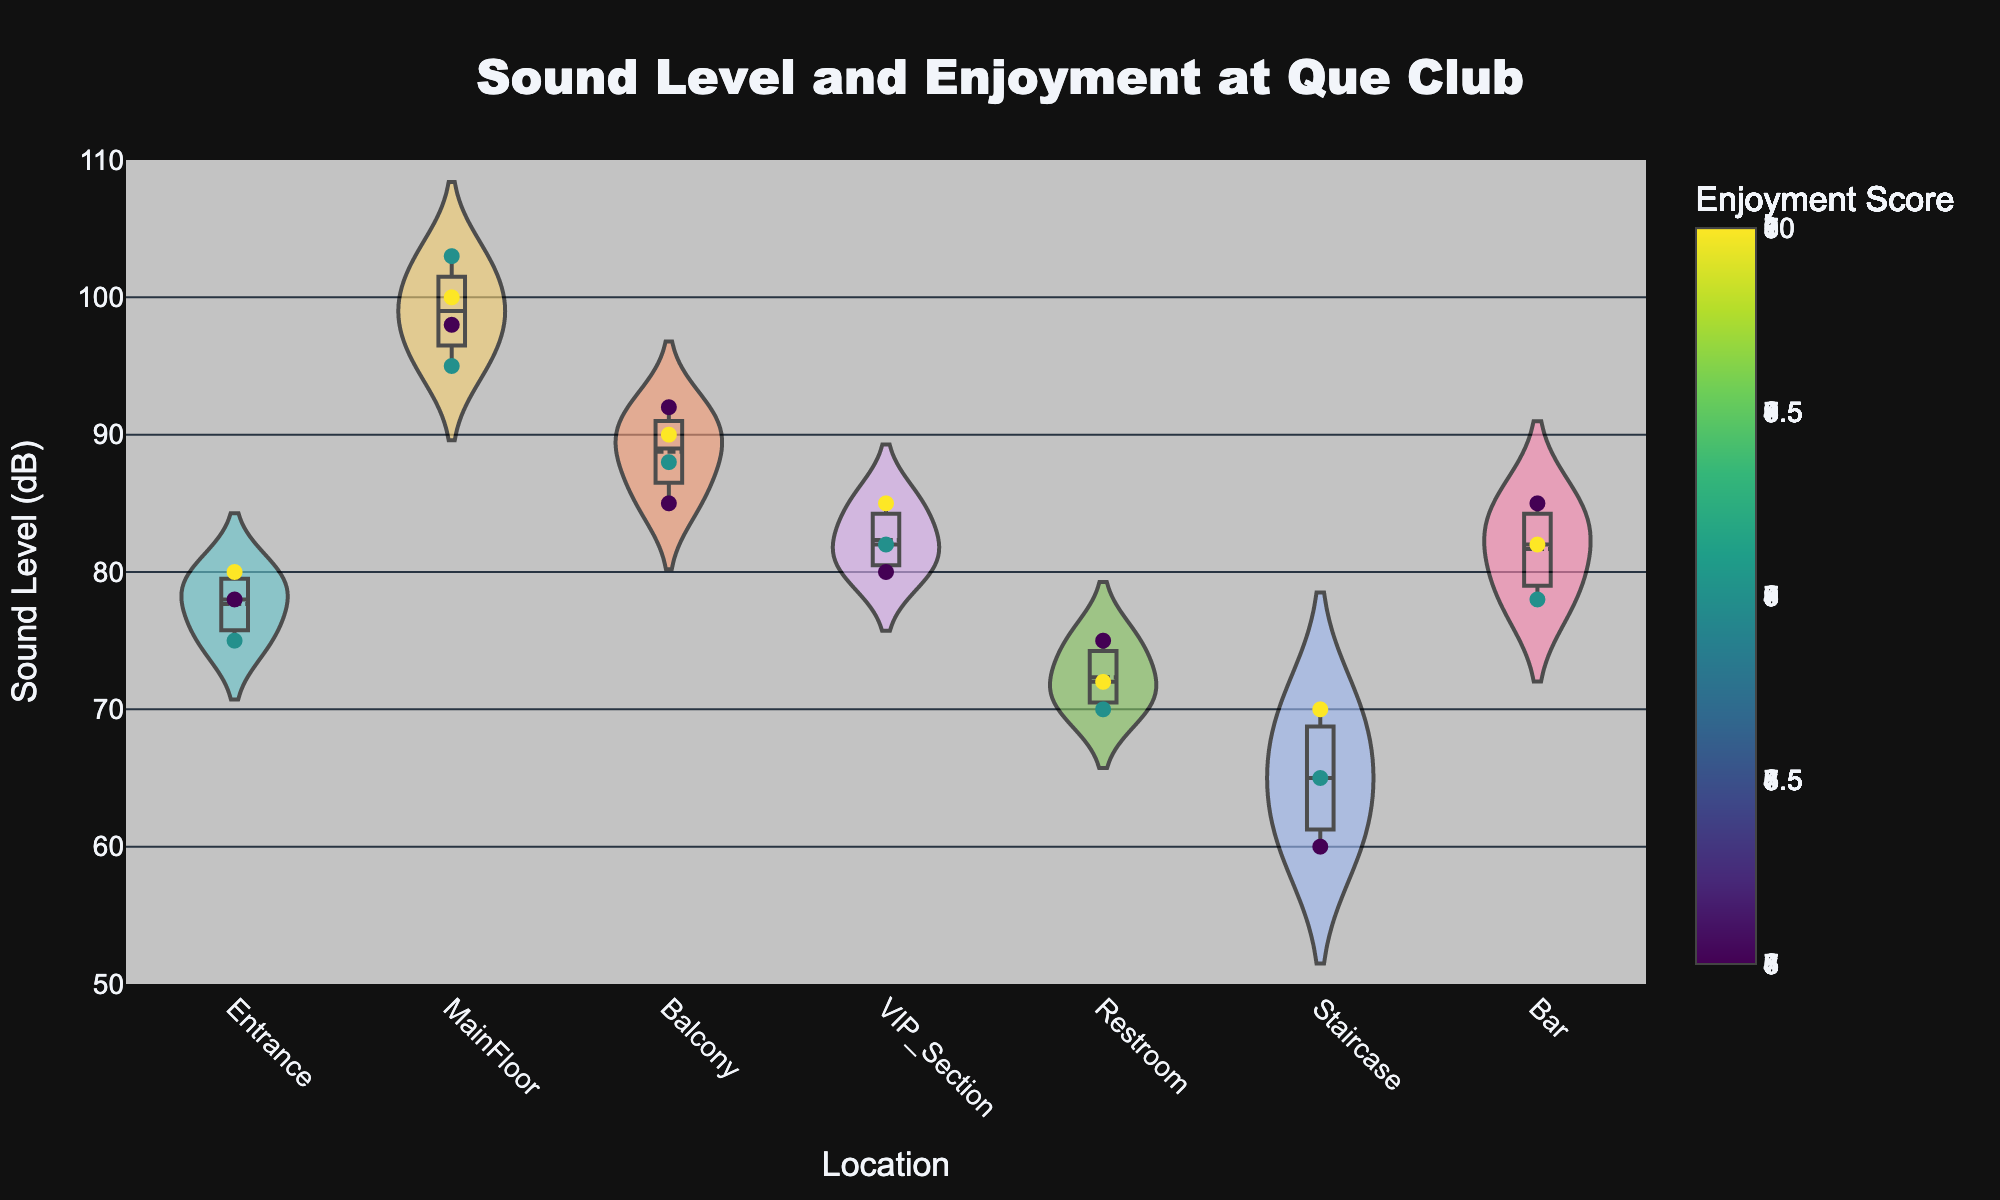How many different locations are shown in the figure? Look at the x-axis to count the unique location names displayed.
Answer: 7 What is the title of the figure? Read the title text displayed at the top of the figure.
Answer: Sound Level and Enjoyment at Que Club Which location has the highest recorded sound level, and what is that level? Find the location with the highest point on the y-axis and note the value.
Answer: MainFloor, 103 dB Which location has the lowest recorded sound level, and what is that level? Find the location with the lowest point on the y-axis and note the value.
Answer: Staircase, 60 dB How many data points are there for the VIP Section? Count the distinct points (dots) within the VIP Section area.
Answer: 3 Which location has the highest median sound level? Look for the center or meanline of the violin plot; compare the main positions of these lines among locations.
Answer: MainFloor Compare the enjoyment scores at the Entrance and Restroom. Where do attendees seem to enjoy more? Analyze the color intensity of the points at Entrance and Restroom; brighter points indicate higher enjoyment scores according to the color bar.
Answer: Entrance On average, do higher sound levels correspond to higher enjoyment scores? Observe the distribution of enjoyment scores indicated by color on the y-axis for points corresponding to higher sound levels.
Answer: Yes Which location has the most spread in sound levels? Look for the violin plot that spans the largest vertical range on the y-axis.
Answer: MainFloor 